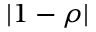Convert formula to latex. <formula><loc_0><loc_0><loc_500><loc_500>| 1 - \rho |</formula> 